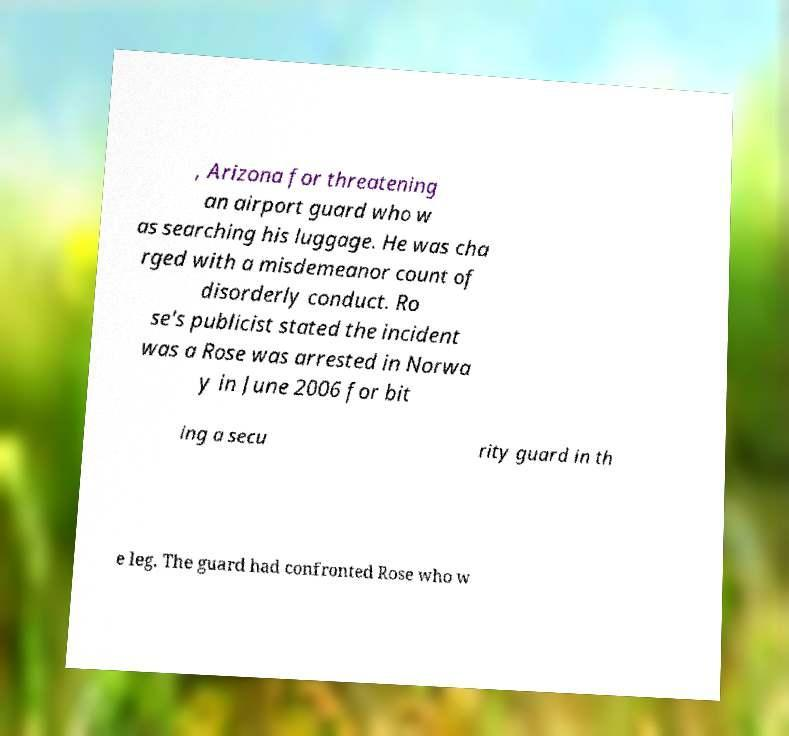Please read and relay the text visible in this image. What does it say? , Arizona for threatening an airport guard who w as searching his luggage. He was cha rged with a misdemeanor count of disorderly conduct. Ro se's publicist stated the incident was a Rose was arrested in Norwa y in June 2006 for bit ing a secu rity guard in th e leg. The guard had confronted Rose who w 